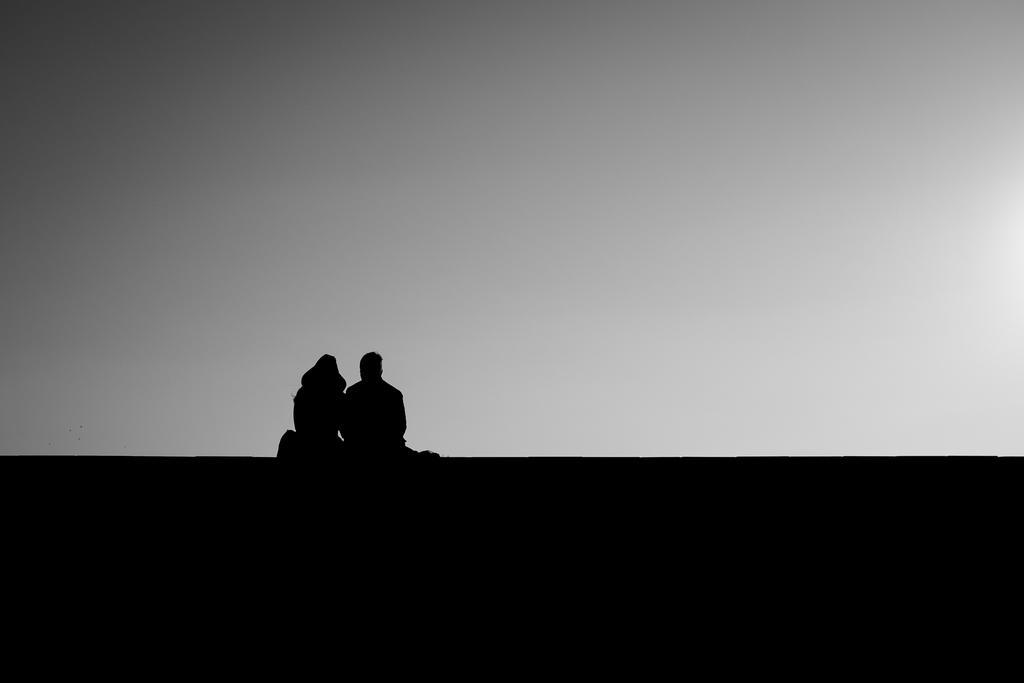In one or two sentences, can you explain what this image depicts? In this image we can see some man and woman sitting. In the background there is a cloudy sky. 